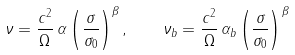<formula> <loc_0><loc_0><loc_500><loc_500>\nu = \frac { c ^ { 2 } } { \Omega } \, \alpha \left ( \frac { \sigma } { \sigma _ { 0 } } \right ) ^ { \beta } , \quad \nu _ { b } = \frac { c ^ { 2 } } { \Omega } \, \alpha _ { b } \left ( \frac { \sigma } { \sigma _ { 0 } } \right ) ^ { \beta }</formula> 